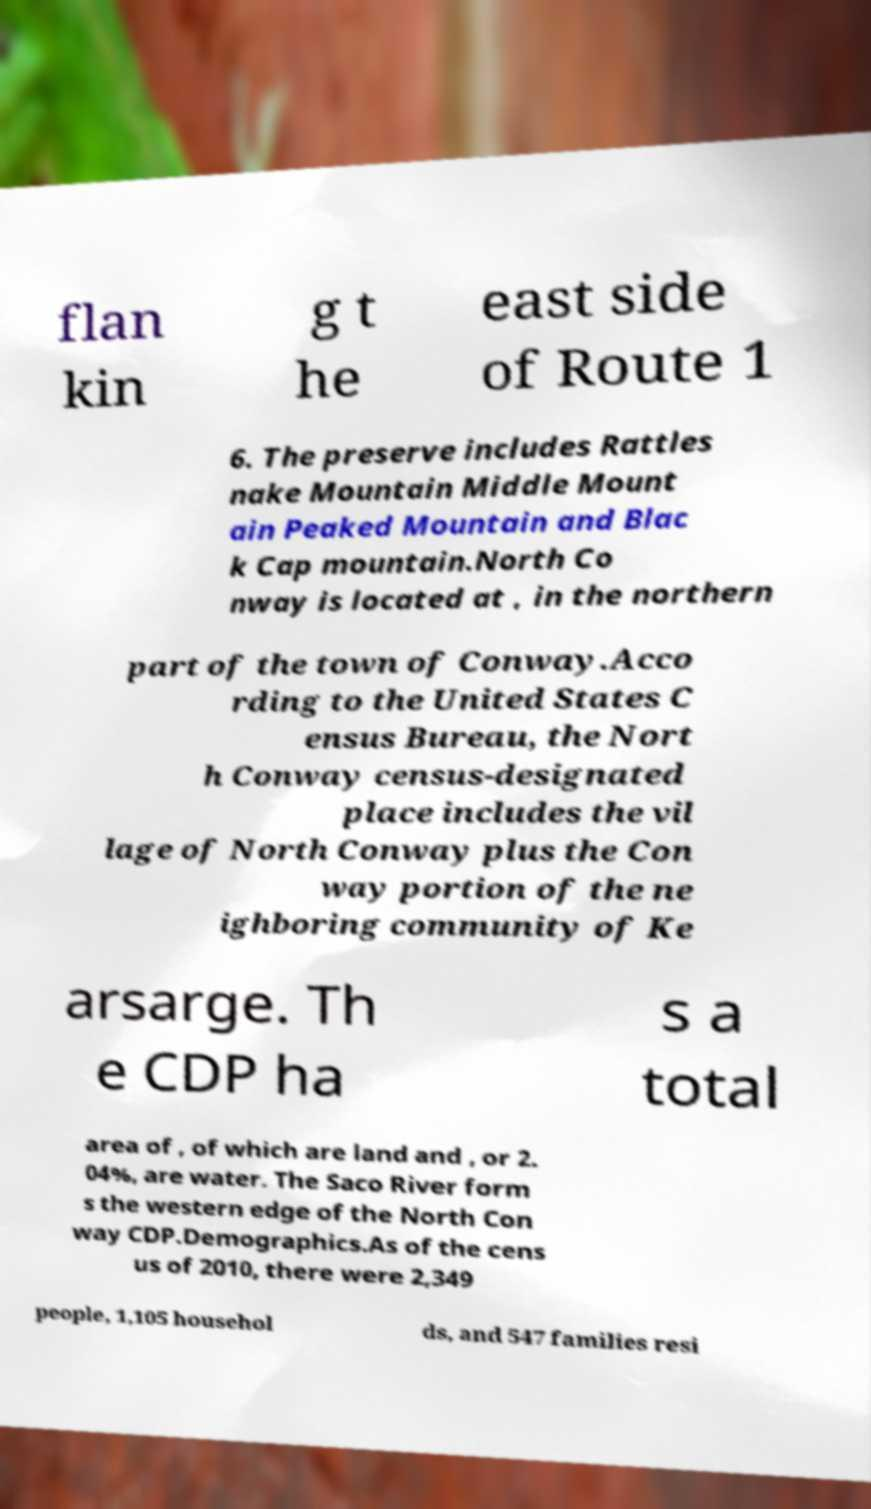Can you accurately transcribe the text from the provided image for me? flan kin g t he east side of Route 1 6. The preserve includes Rattles nake Mountain Middle Mount ain Peaked Mountain and Blac k Cap mountain.North Co nway is located at , in the northern part of the town of Conway.Acco rding to the United States C ensus Bureau, the Nort h Conway census-designated place includes the vil lage of North Conway plus the Con way portion of the ne ighboring community of Ke arsarge. Th e CDP ha s a total area of , of which are land and , or 2. 04%, are water. The Saco River form s the western edge of the North Con way CDP.Demographics.As of the cens us of 2010, there were 2,349 people, 1,105 househol ds, and 547 families resi 